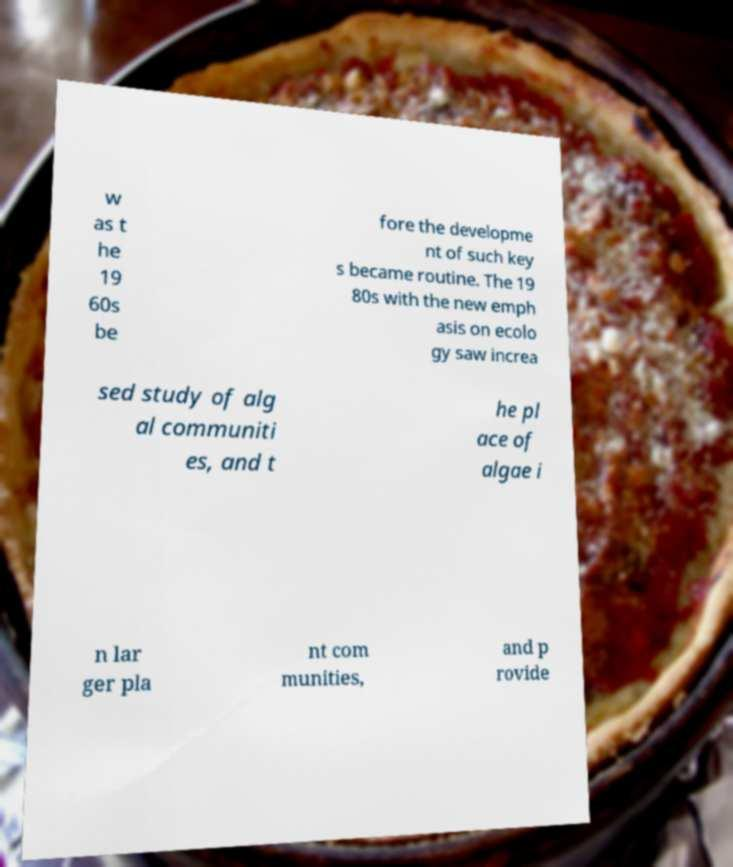For documentation purposes, I need the text within this image transcribed. Could you provide that? w as t he 19 60s be fore the developme nt of such key s became routine. The 19 80s with the new emph asis on ecolo gy saw increa sed study of alg al communiti es, and t he pl ace of algae i n lar ger pla nt com munities, and p rovide 